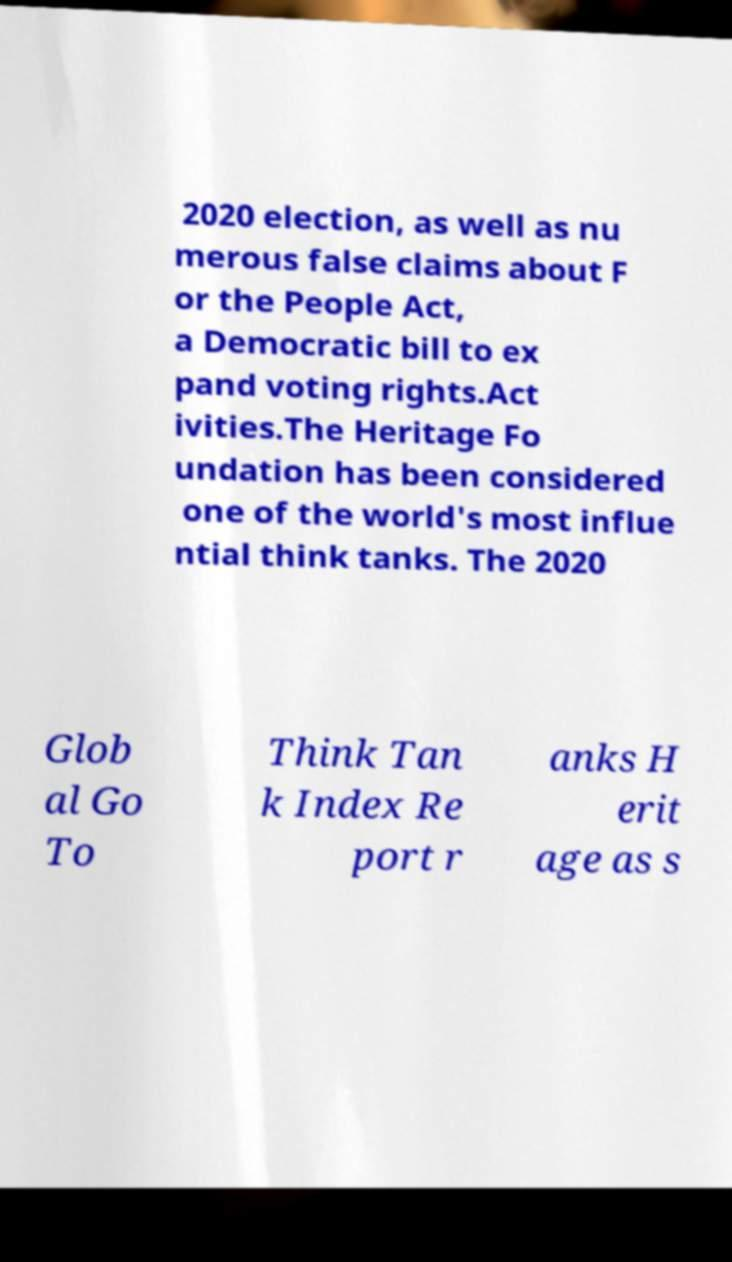Please read and relay the text visible in this image. What does it say? 2020 election, as well as nu merous false claims about F or the People Act, a Democratic bill to ex pand voting rights.Act ivities.The Heritage Fo undation has been considered one of the world's most influe ntial think tanks. The 2020 Glob al Go To Think Tan k Index Re port r anks H erit age as s 